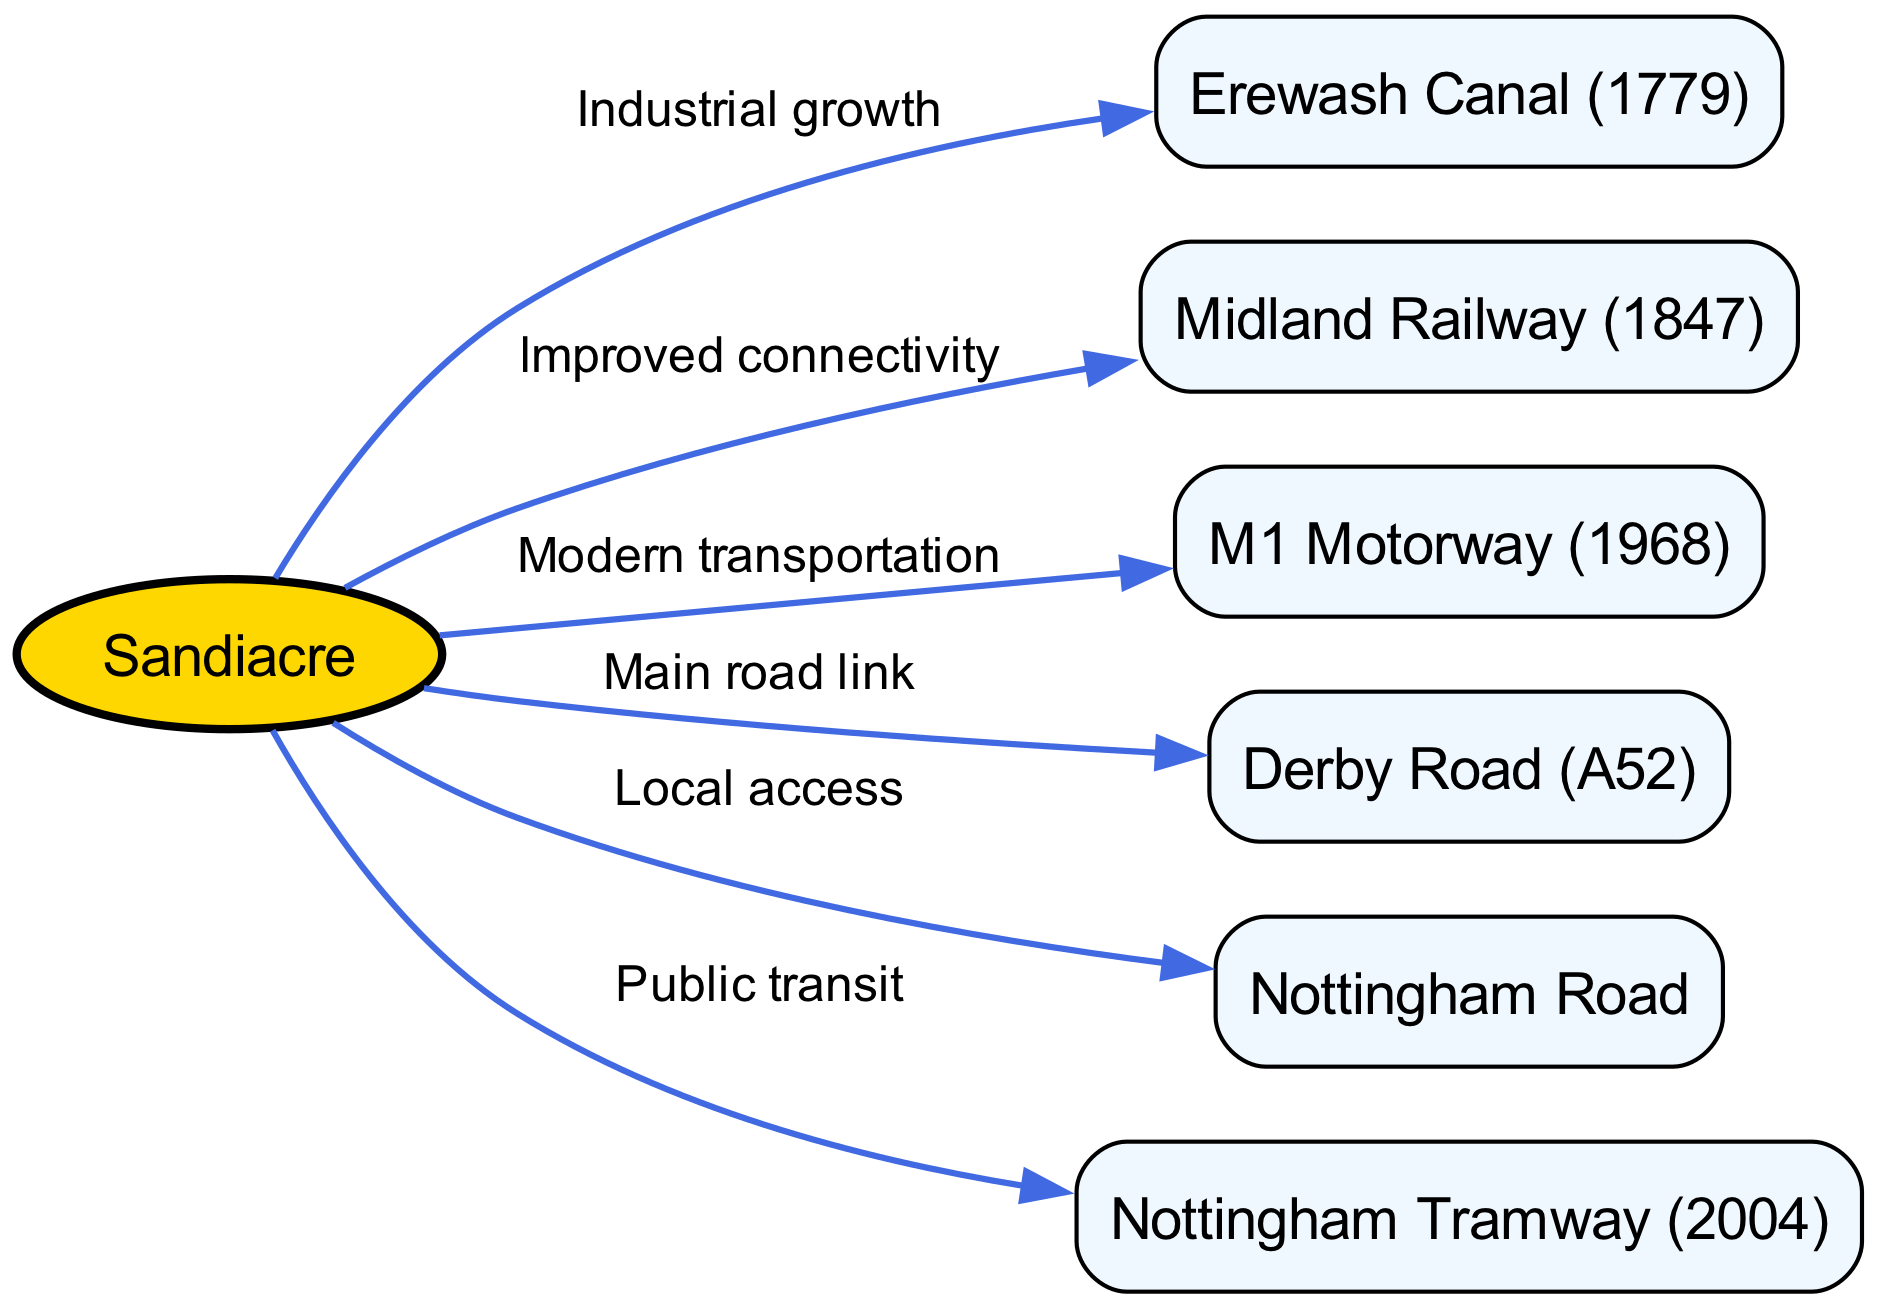What is the year of the Erewash Canal's establishment? The Erewash Canal is specified in the diagram to have been established in 1779, as indicated in the node label.
Answer: 1779 How many nodes are present in the diagram? By counting the nodes listed in the "nodes" section of the data, we find there are six distinct nodes: Sandiacre, Erewash Canal, Midland Railway, M1 Motorway, Derby Road, Nottingham Road, and Nottingham Tramway.
Answer: 6 What is the main road link from Sandiacre? The diagram indicates that Derby Road (A52) is the primary road link from Sandiacre, as it is directly connected to the Sandiacre node with a labeled edge.
Answer: Derby Road (A52) What is the connection between Sandiacre and the Nottingham Tramway? The connection is labeled as "Public transit," showing that Sandiacre is linked to the Nottingham Tramway, emphasizing its role in transportation options.
Answer: Public transit Which transportation system improved connectivity in Sandiacre? The Midland Railway is specifically noted as the transportation system that improved connectivity, as indicated by the edge labeled "Improved connectivity."
Answer: Midland Railway What are the two types of roads mentioned in the diagram connected to Sandiacre? The two types of roads are Derby Road (A52) and Nottingham Road, both of which are directly linked to the Sandiacre node in the diagram.
Answer: Derby Road (A52) and Nottingham Road What was the year of the establishment of the M1 Motorway? According to the diagram, the M1 Motorway was established in 1968, as stated in the node label reflecting its historical significance.
Answer: 1968 How is the Erewash Canal related to Sandiacre in the context of transportation? The Erewash Canal is connected to Sandiacre by the edge labeled "Industrial growth," indicating that the canal played a significant role during Sandiacre's industrial development.
Answer: Industrial growth What type of transportation system was established in Sandiacre in 2004? The Nottingham Tramway, established in 2004, is noted in the diagram as a public transit system, which enhances transport options in the area.
Answer: Nottingham Tramway 